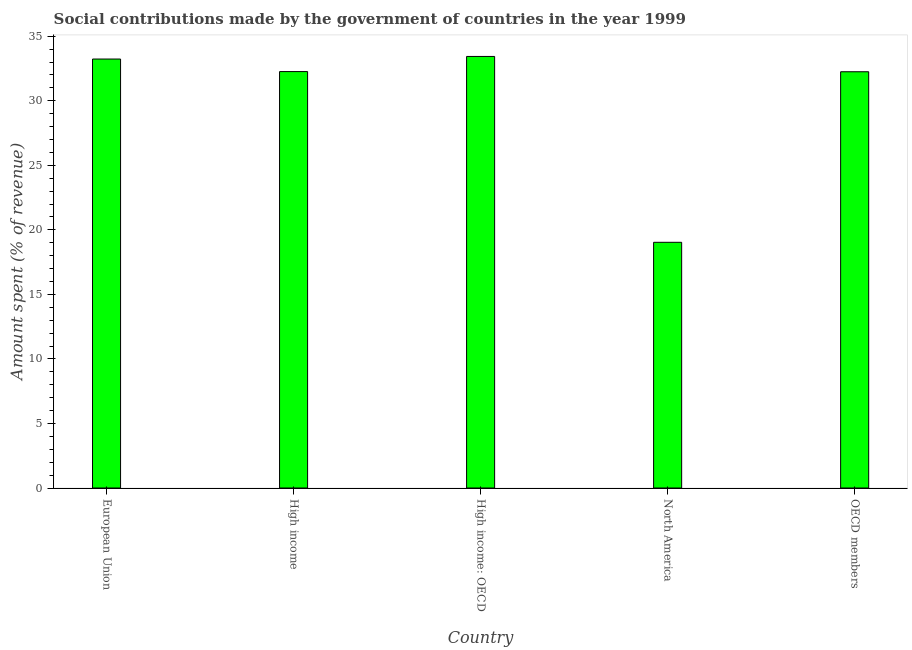What is the title of the graph?
Provide a succinct answer. Social contributions made by the government of countries in the year 1999. What is the label or title of the Y-axis?
Your response must be concise. Amount spent (% of revenue). What is the amount spent in making social contributions in High income: OECD?
Your answer should be compact. 33.43. Across all countries, what is the maximum amount spent in making social contributions?
Offer a very short reply. 33.43. Across all countries, what is the minimum amount spent in making social contributions?
Offer a terse response. 19.03. In which country was the amount spent in making social contributions maximum?
Provide a short and direct response. High income: OECD. In which country was the amount spent in making social contributions minimum?
Give a very brief answer. North America. What is the sum of the amount spent in making social contributions?
Your response must be concise. 150.21. What is the difference between the amount spent in making social contributions in High income: OECD and North America?
Keep it short and to the point. 14.4. What is the average amount spent in making social contributions per country?
Your answer should be very brief. 30.04. What is the median amount spent in making social contributions?
Your response must be concise. 32.26. Is the amount spent in making social contributions in High income less than that in North America?
Your answer should be compact. No. In how many countries, is the amount spent in making social contributions greater than the average amount spent in making social contributions taken over all countries?
Make the answer very short. 4. Are all the bars in the graph horizontal?
Provide a succinct answer. No. Are the values on the major ticks of Y-axis written in scientific E-notation?
Provide a short and direct response. No. What is the Amount spent (% of revenue) of European Union?
Give a very brief answer. 33.23. What is the Amount spent (% of revenue) in High income?
Give a very brief answer. 32.26. What is the Amount spent (% of revenue) of High income: OECD?
Keep it short and to the point. 33.43. What is the Amount spent (% of revenue) of North America?
Your answer should be compact. 19.03. What is the Amount spent (% of revenue) of OECD members?
Make the answer very short. 32.25. What is the difference between the Amount spent (% of revenue) in European Union and High income?
Your answer should be compact. 0.97. What is the difference between the Amount spent (% of revenue) in European Union and High income: OECD?
Offer a terse response. -0.2. What is the difference between the Amount spent (% of revenue) in European Union and North America?
Make the answer very short. 14.2. What is the difference between the Amount spent (% of revenue) in European Union and OECD members?
Your answer should be very brief. 0.99. What is the difference between the Amount spent (% of revenue) in High income and High income: OECD?
Your answer should be very brief. -1.17. What is the difference between the Amount spent (% of revenue) in High income and North America?
Offer a very short reply. 13.23. What is the difference between the Amount spent (% of revenue) in High income and OECD members?
Your response must be concise. 0.01. What is the difference between the Amount spent (% of revenue) in High income: OECD and North America?
Your answer should be compact. 14.4. What is the difference between the Amount spent (% of revenue) in High income: OECD and OECD members?
Provide a short and direct response. 1.19. What is the difference between the Amount spent (% of revenue) in North America and OECD members?
Give a very brief answer. -13.21. What is the ratio of the Amount spent (% of revenue) in European Union to that in High income: OECD?
Keep it short and to the point. 0.99. What is the ratio of the Amount spent (% of revenue) in European Union to that in North America?
Your answer should be very brief. 1.75. What is the ratio of the Amount spent (% of revenue) in European Union to that in OECD members?
Your answer should be compact. 1.03. What is the ratio of the Amount spent (% of revenue) in High income to that in North America?
Ensure brevity in your answer.  1.7. What is the ratio of the Amount spent (% of revenue) in High income to that in OECD members?
Make the answer very short. 1. What is the ratio of the Amount spent (% of revenue) in High income: OECD to that in North America?
Provide a succinct answer. 1.76. What is the ratio of the Amount spent (% of revenue) in North America to that in OECD members?
Your response must be concise. 0.59. 